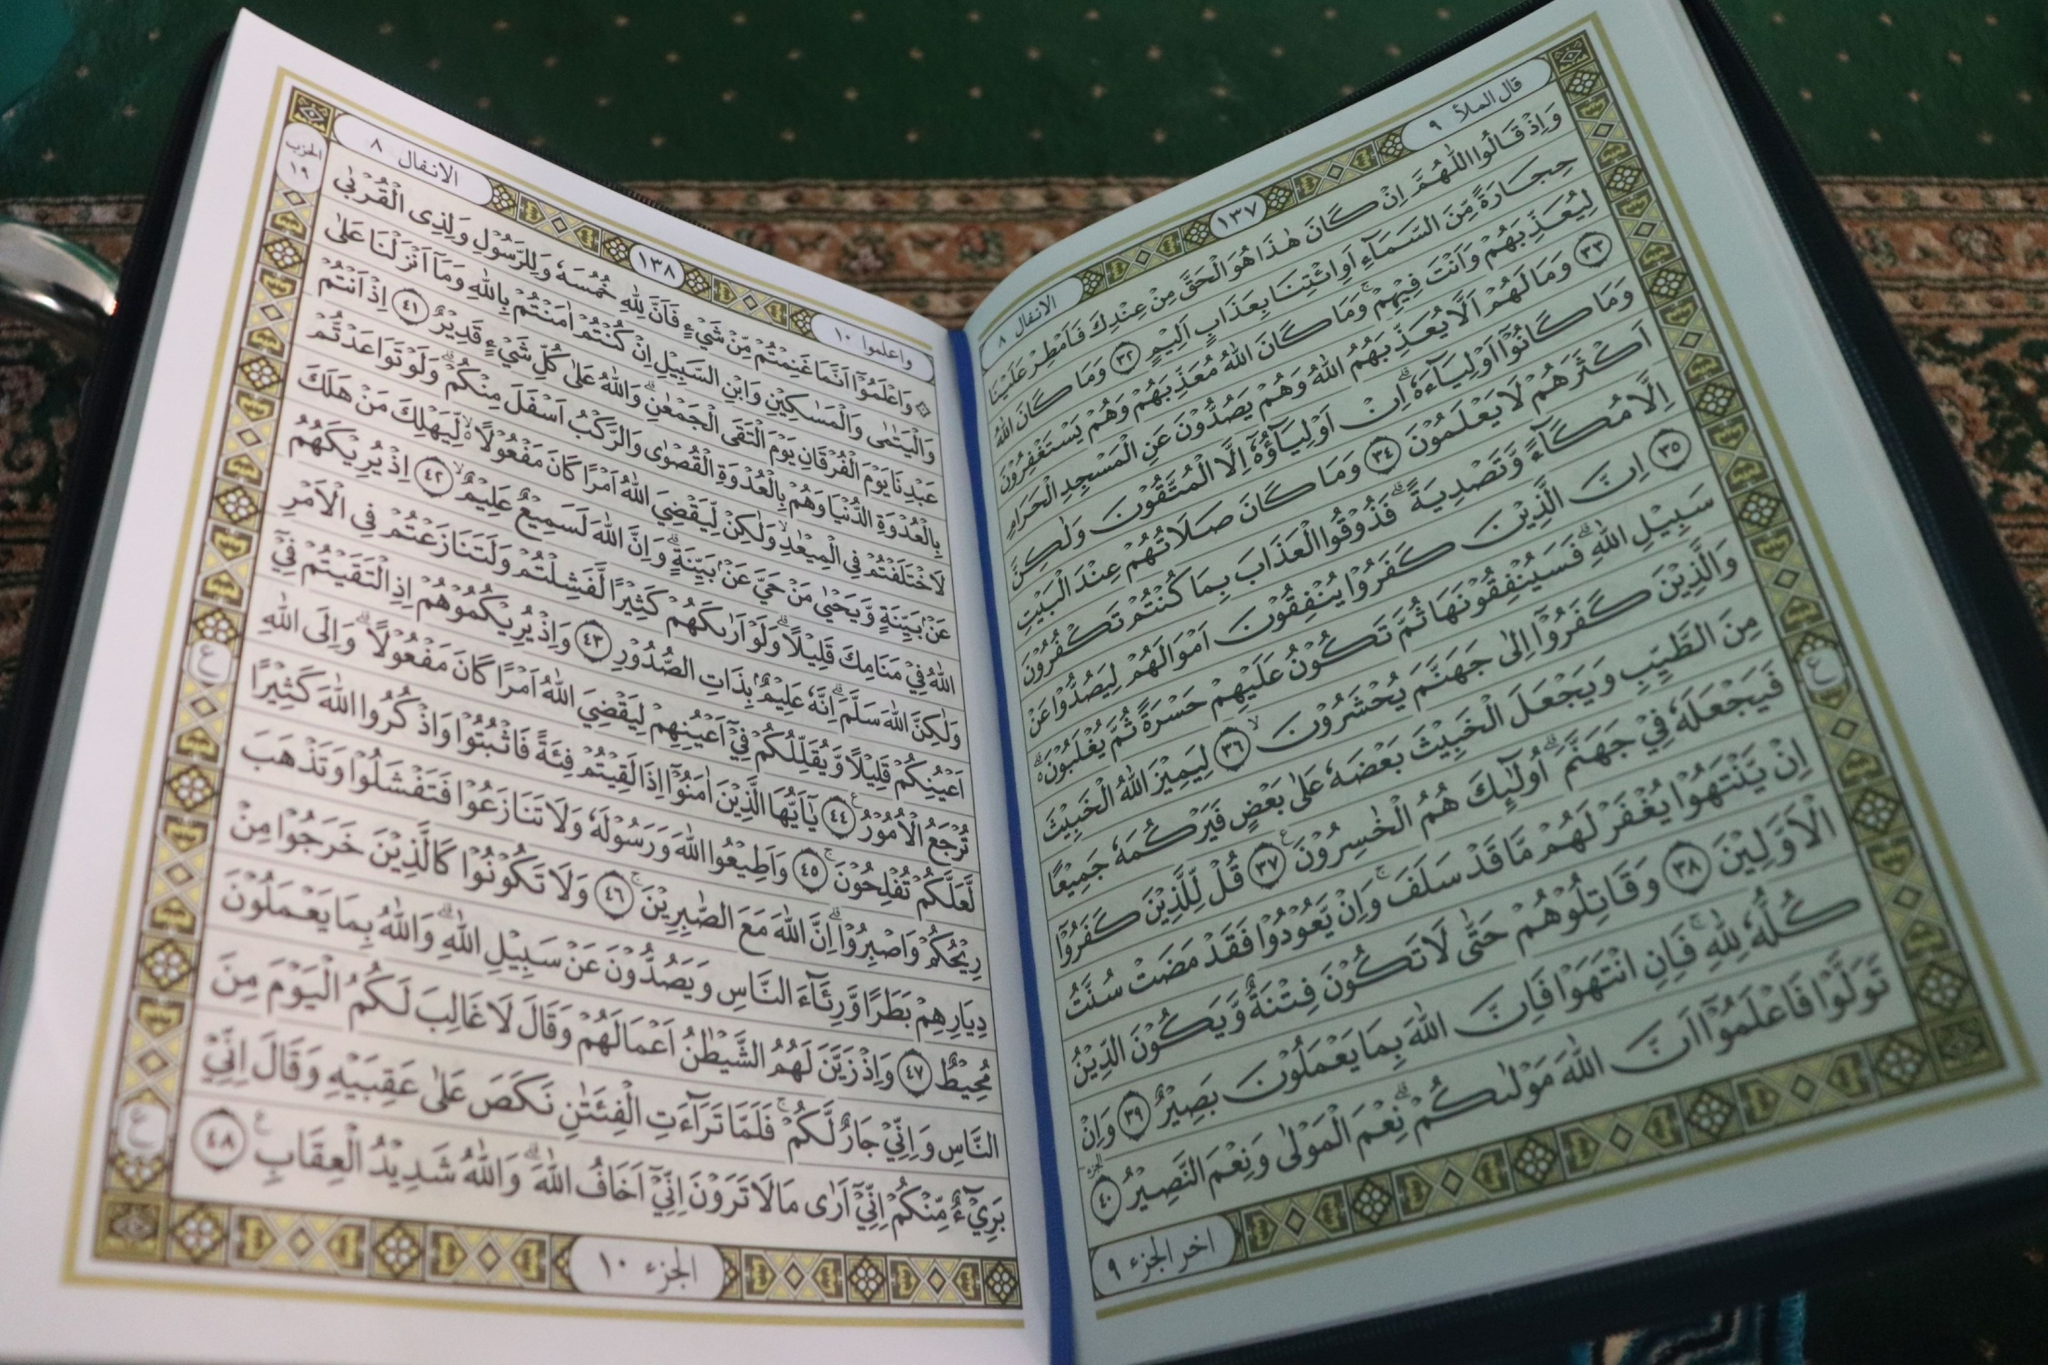What significance might this book hold for people who read it? This book is significant for readers as it serves as a spiritual and moral guide. It is likely a Holy Scripture, providing wisdom, commandments, and teachings that followers use in their daily lives to seek moral and spiritual guidance, find comfort in times of distress, and connect with their faith and tradition. It may also play a central role in religious ceremonies and practices. 